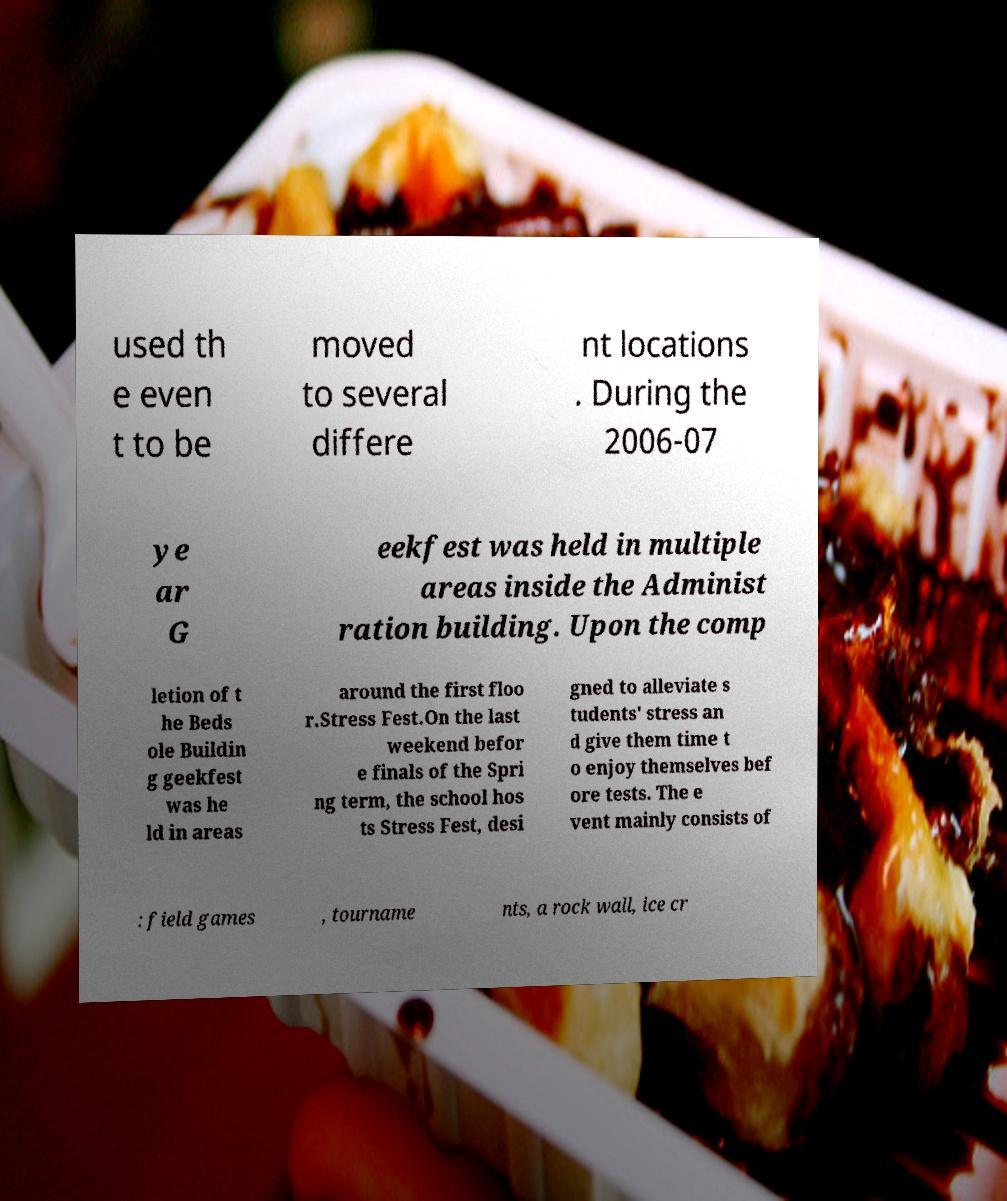I need the written content from this picture converted into text. Can you do that? used th e even t to be moved to several differe nt locations . During the 2006-07 ye ar G eekfest was held in multiple areas inside the Administ ration building. Upon the comp letion of t he Beds ole Buildin g geekfest was he ld in areas around the first floo r.Stress Fest.On the last weekend befor e finals of the Spri ng term, the school hos ts Stress Fest, desi gned to alleviate s tudents' stress an d give them time t o enjoy themselves bef ore tests. The e vent mainly consists of : field games , tourname nts, a rock wall, ice cr 